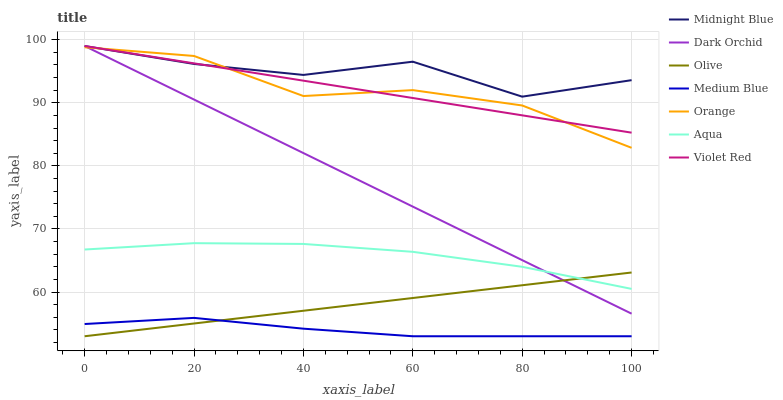Does Medium Blue have the minimum area under the curve?
Answer yes or no. Yes. Does Midnight Blue have the maximum area under the curve?
Answer yes or no. Yes. Does Midnight Blue have the minimum area under the curve?
Answer yes or no. No. Does Medium Blue have the maximum area under the curve?
Answer yes or no. No. Is Violet Red the smoothest?
Answer yes or no. Yes. Is Midnight Blue the roughest?
Answer yes or no. Yes. Is Medium Blue the smoothest?
Answer yes or no. No. Is Medium Blue the roughest?
Answer yes or no. No. Does Midnight Blue have the lowest value?
Answer yes or no. No. Does Medium Blue have the highest value?
Answer yes or no. No. Is Aqua less than Orange?
Answer yes or no. Yes. Is Violet Red greater than Aqua?
Answer yes or no. Yes. Does Aqua intersect Orange?
Answer yes or no. No. 